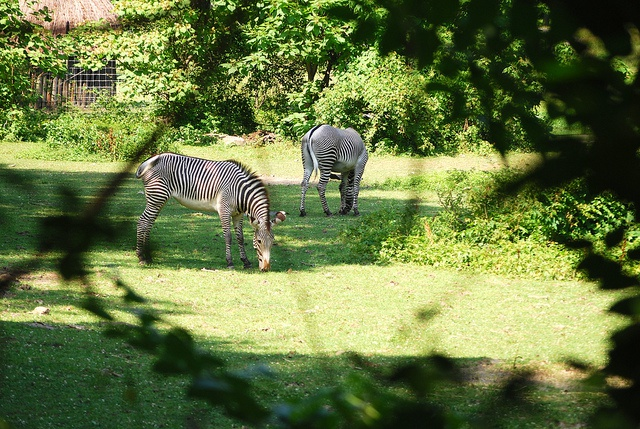Describe the objects in this image and their specific colors. I can see zebra in lightgreen, black, gray, ivory, and darkgray tones and zebra in lightgreen, gray, darkgray, black, and lightgray tones in this image. 